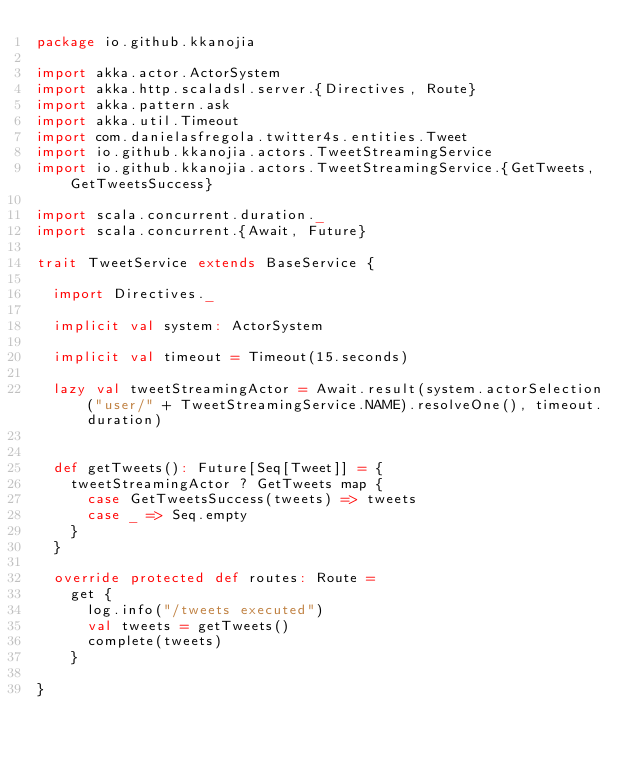<code> <loc_0><loc_0><loc_500><loc_500><_Scala_>package io.github.kkanojia

import akka.actor.ActorSystem
import akka.http.scaladsl.server.{Directives, Route}
import akka.pattern.ask
import akka.util.Timeout
import com.danielasfregola.twitter4s.entities.Tweet
import io.github.kkanojia.actors.TweetStreamingService
import io.github.kkanojia.actors.TweetStreamingService.{GetTweets, GetTweetsSuccess}

import scala.concurrent.duration._
import scala.concurrent.{Await, Future}

trait TweetService extends BaseService {

  import Directives._

  implicit val system: ActorSystem

  implicit val timeout = Timeout(15.seconds)

  lazy val tweetStreamingActor = Await.result(system.actorSelection("user/" + TweetStreamingService.NAME).resolveOne(), timeout.duration)


  def getTweets(): Future[Seq[Tweet]] = {
    tweetStreamingActor ? GetTweets map {
      case GetTweetsSuccess(tweets) => tweets
      case _ => Seq.empty
    }
  }

  override protected def routes: Route =
    get {
      log.info("/tweets executed")
      val tweets = getTweets()
      complete(tweets)
    }

}

</code> 